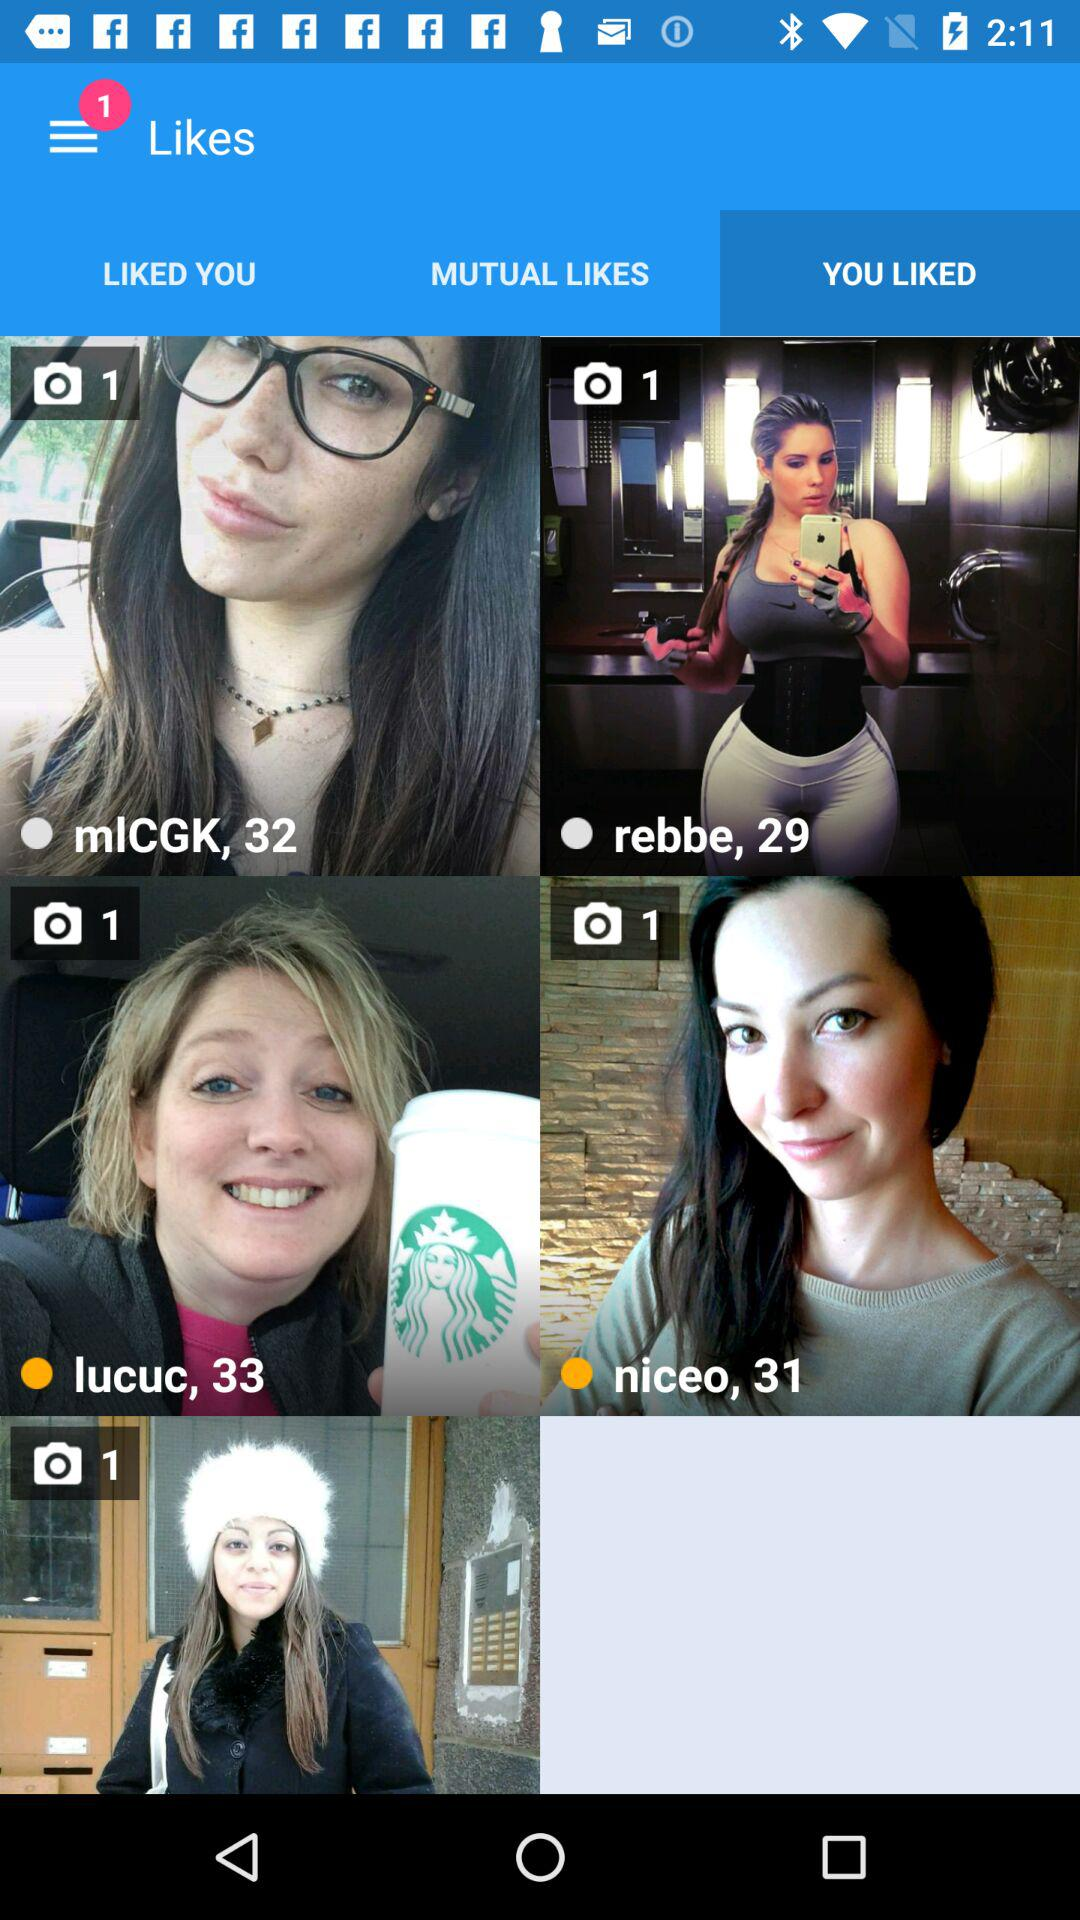What's the age of Lucuc? The age of Lucuc is 33 years. 